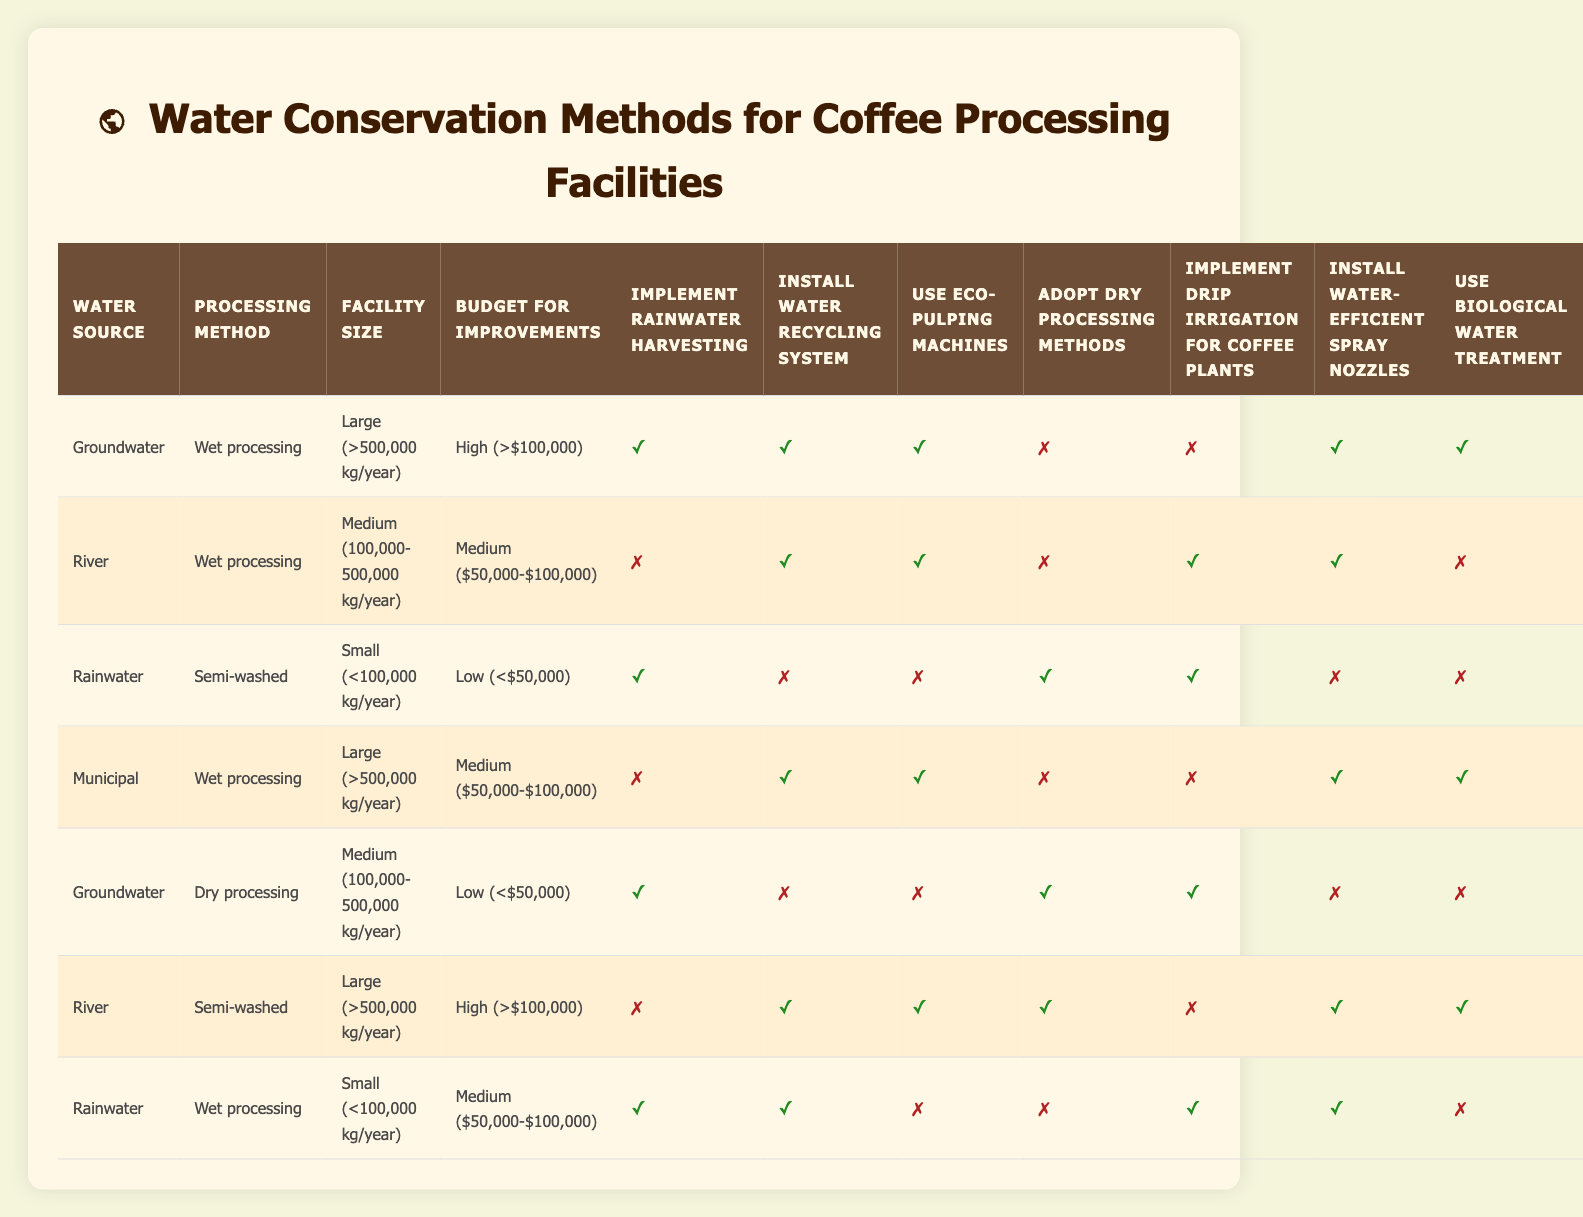What are the available water conservation methods for facilities using groundwater with a high budget? From the table, we look for the row where the water source is "Groundwater," the budget is "High (> $100,000)," and find that the actions that can be implemented include rainwater harvesting, installing a water recycling system, using eco-pulping machines, installing water-efficient spray nozzles, and using biological water treatment.
Answer: Rainwater harvesting, install water recycling system, use eco-pulping machines, install water-efficient spray nozzles, use biological water treatment Which processing method has the possibility of using drip irrigation for coffee plants in a medium-sized facility? Locating medium-sized facilities, we check the actions available. The rows for this size indicate that "Wet processing" allows for implementing drip irrigation. The corresponding row is the one with the river as a water source.
Answer: Wet processing Is it possible for a small facility using rainwater to implement all conservation methods? We check the row with rainwater as a source and small facility size. Upon looking closely, the actions include rainwater harvesting, adopting dry processing methods, and implementing drip irrigation, but water recycling, eco-pulping, and biological water treatment are not options. Therefore, not all methods can be implemented.
Answer: No How many conservation actions can a large facility using river water and high budget implement? We identify the row where the facility is large, the water source is "River," and the budget is "High (> $100,000)." The actions are: install a water recycling system, use eco-pulping machines, adopt dry processing methods, install water-efficient spray nozzles, and use biological treatment. Adding these gives us a total of five actions.
Answer: Five actions Are there options for medium-sized facilities on a low budget using groundwater? Checking for medium-sized facilities in the table with groundwater as a source and a low budget, we look for actions that can be implemented. We find the actions of implementing rainwater harvesting, adopting dry processing methods, and using drip irrigation. Thus, there are options available even with the low budget.
Answer: Yes 